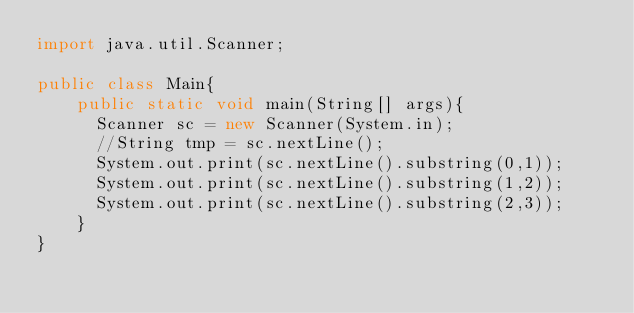Convert code to text. <code><loc_0><loc_0><loc_500><loc_500><_Java_>import java.util.Scanner;

public class Main{
    public static void main(String[] args){
			Scanner sc = new Scanner(System.in);
			//String tmp = sc.nextLine();
			System.out.print(sc.nextLine().substring(0,1));
			System.out.print(sc.nextLine().substring(1,2));
			System.out.print(sc.nextLine().substring(2,3));
    }
}
</code> 